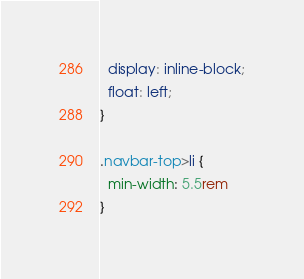Convert code to text. <code><loc_0><loc_0><loc_500><loc_500><_CSS_>  display: inline-block;
  float: left;
}

.navbar-top>li {
  min-width: 5.5rem
}
</code> 